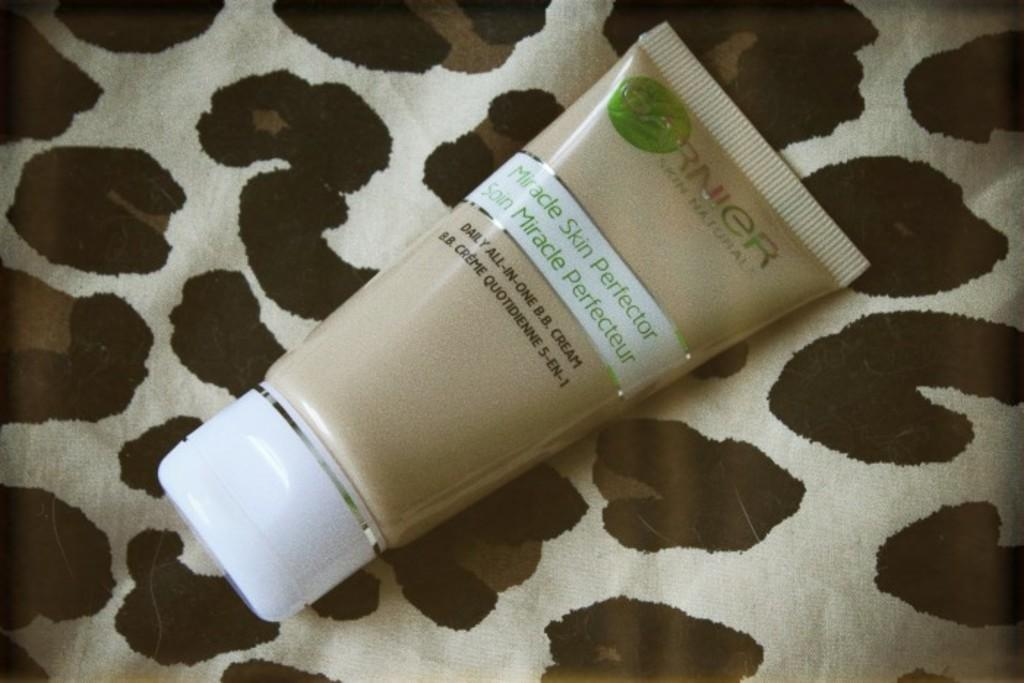<image>
Relay a brief, clear account of the picture shown. A bottle of skin cream by Garnier sits on a blanket. 